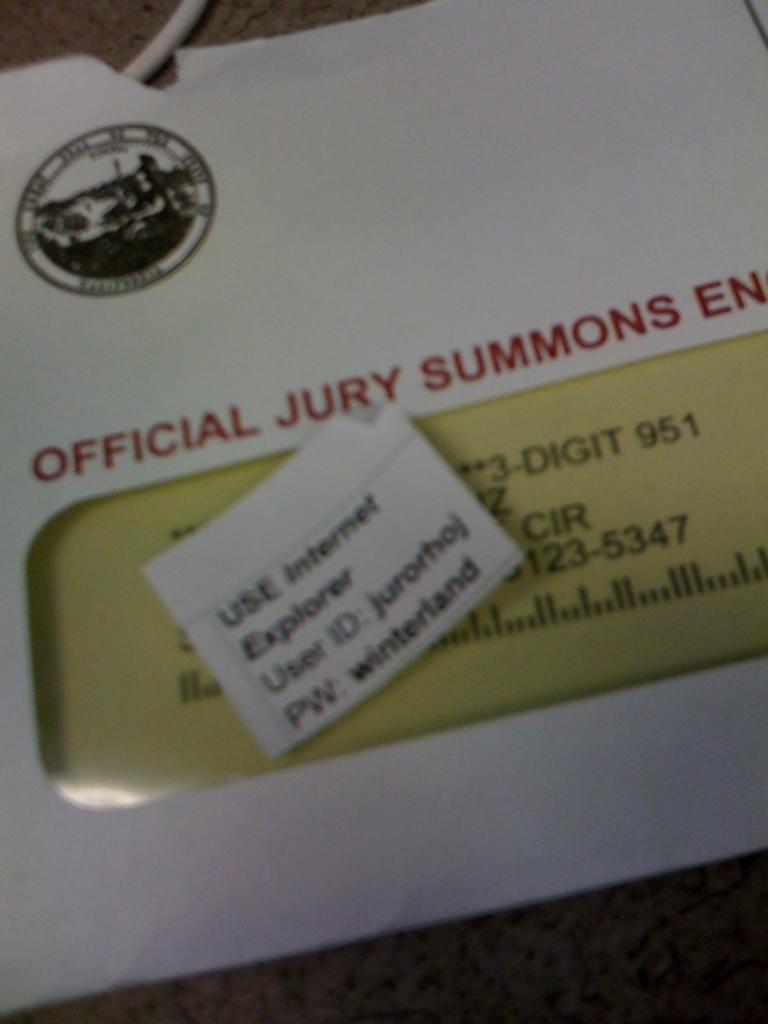Provide a one-sentence caption for the provided image. The writing on the envelope indicates it contains a jury summons. 